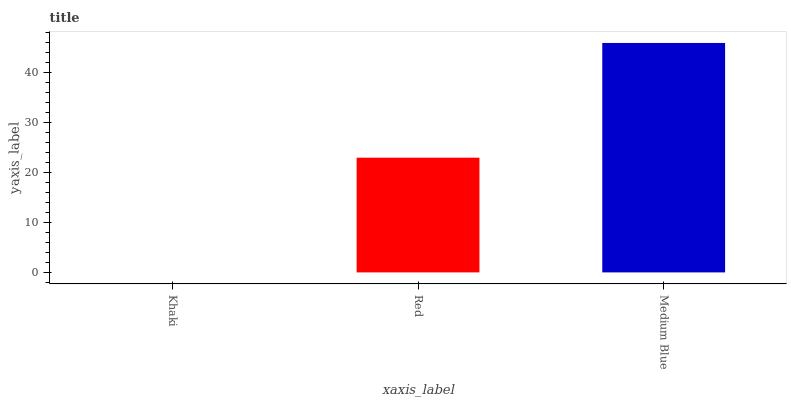Is Khaki the minimum?
Answer yes or no. Yes. Is Medium Blue the maximum?
Answer yes or no. Yes. Is Red the minimum?
Answer yes or no. No. Is Red the maximum?
Answer yes or no. No. Is Red greater than Khaki?
Answer yes or no. Yes. Is Khaki less than Red?
Answer yes or no. Yes. Is Khaki greater than Red?
Answer yes or no. No. Is Red less than Khaki?
Answer yes or no. No. Is Red the high median?
Answer yes or no. Yes. Is Red the low median?
Answer yes or no. Yes. Is Khaki the high median?
Answer yes or no. No. Is Medium Blue the low median?
Answer yes or no. No. 